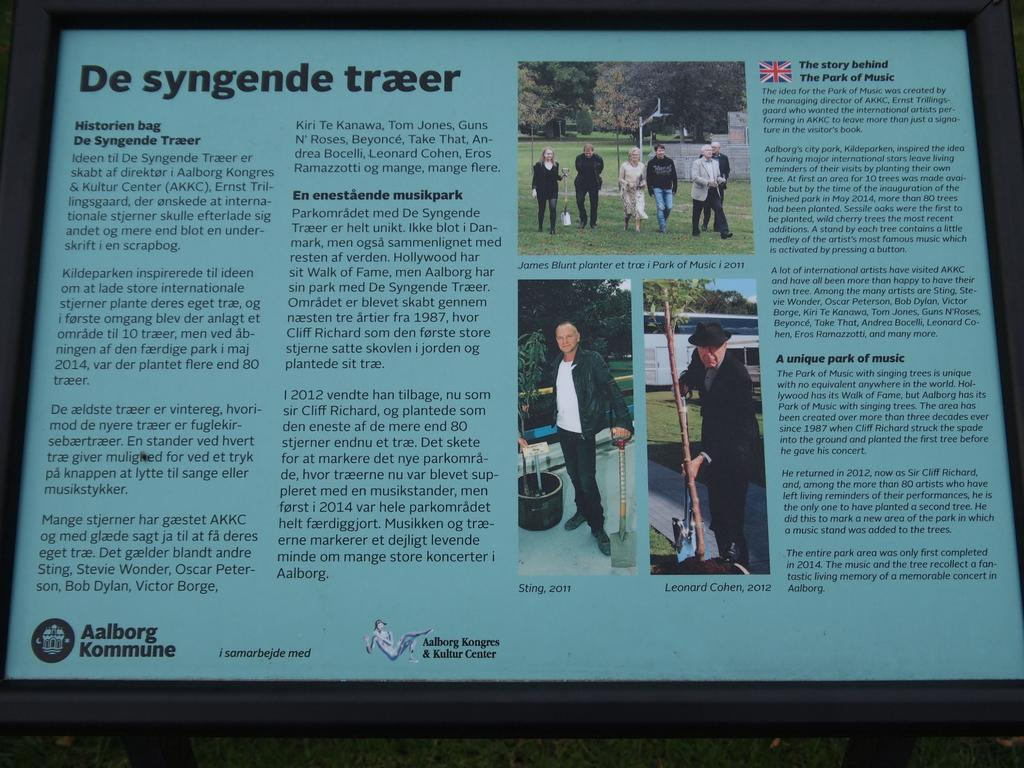<image>
Present a compact description of the photo's key features. An article released Aalborg Kongres & Kultur Center has a British article called "The Story behind The Park of Music" 